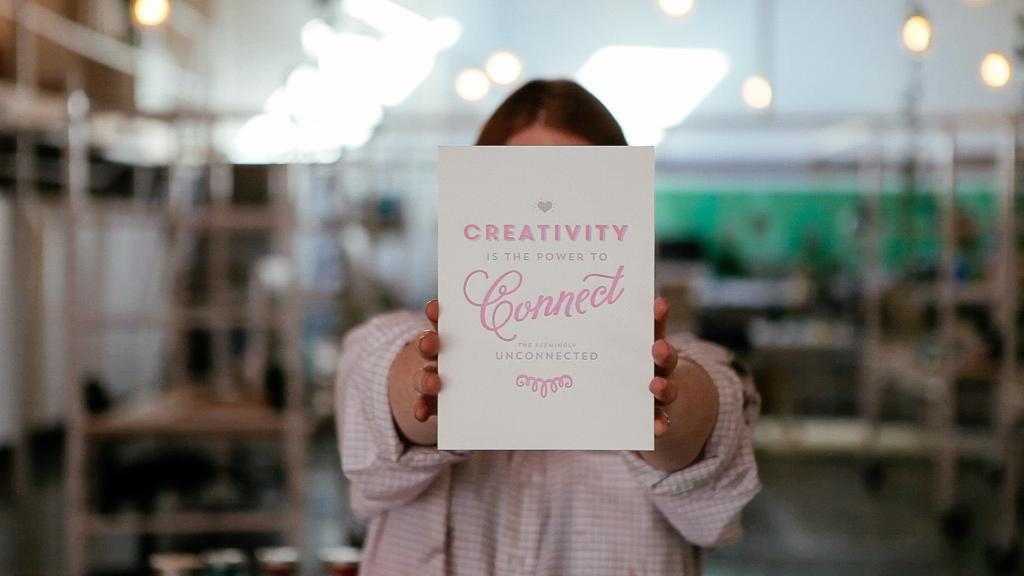Who or what is present in the image? There is a person in the image. What is the person holding? The person is holding a sheet. Can you describe the sheet? The sheet has something written on it. What else can be seen in the image? There are other objects in the background of the image. How many carts are visible in the image? There is no cart present in the image. Are there any giants visible in the image? There are no giants present in the image. 